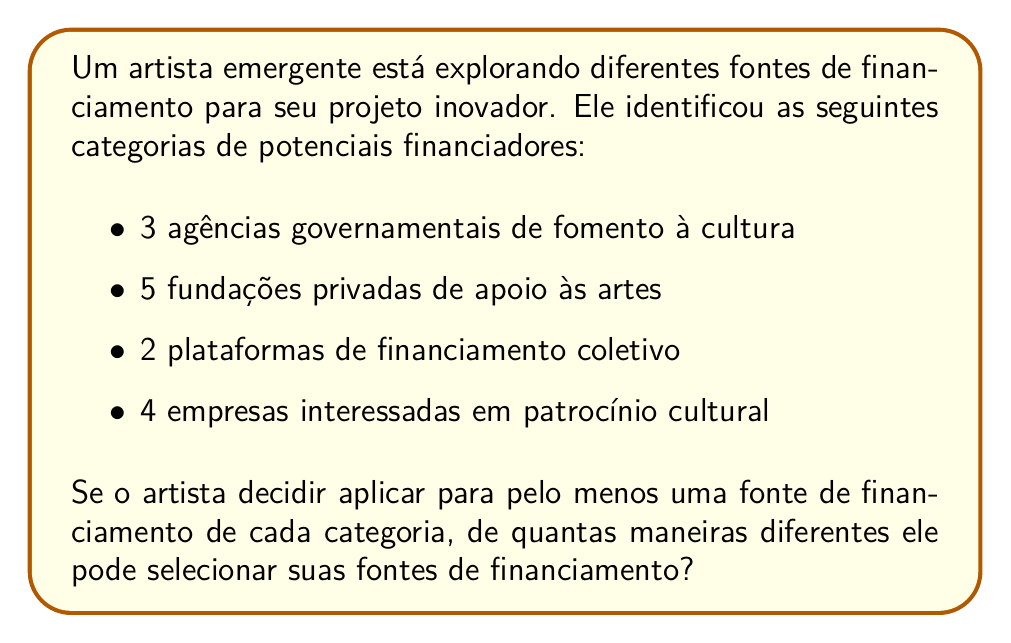Could you help me with this problem? Para resolver este problema, vamos usar o princípio multiplicativo da contagem.

1) Para cada categoria, o artista tem as seguintes opções:

   - Agências governamentais: $2^3 - 1 = 7$ opções (todas as combinações possíveis exceto não escolher nenhuma)
   - Fundações privadas: $2^5 - 1 = 31$ opções
   - Plataformas de financiamento coletivo: $2^2 - 1 = 3$ opções
   - Empresas patrocinadoras: $2^4 - 1 = 15$ opções

2) Usamos $2^n - 1$ para cada categoria porque:
   - $2^n$ representa todas as combinações possíveis (incluindo não escolher nenhuma)
   - Subtraímos 1 para excluir a opção de não escolher nenhuma, já que o artista deve escolher pelo menos uma de cada categoria

3) Pelo princípio multiplicativo, o número total de maneiras de selecionar as fontes de financiamento é:

   $$(2^3 - 1) \cdot (2^5 - 1) \cdot (2^2 - 1) \cdot (2^4 - 1)$$

4) Substituindo os valores:

   $$7 \cdot 31 \cdot 3 \cdot 15 = 9765$$

Portanto, o artista tem 9765 maneiras diferentes de selecionar suas fontes de financiamento.
Answer: 9765 maneiras diferentes 